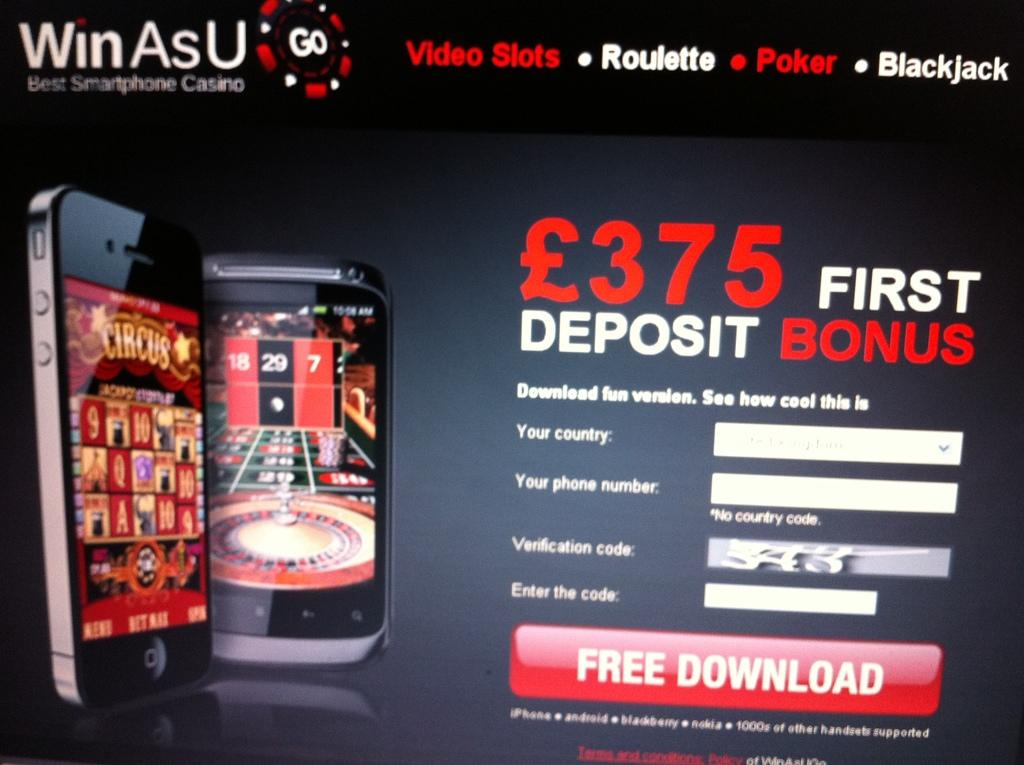<image>
Share a concise interpretation of the image provided. a phone that is priced at 375 dollars 